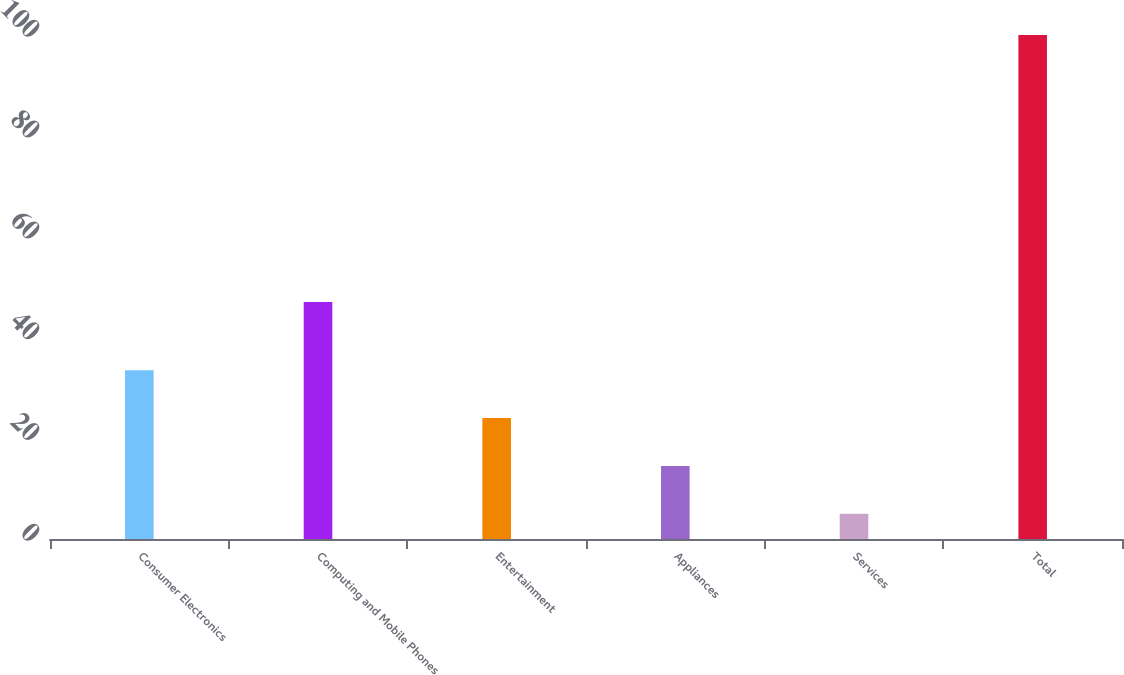<chart> <loc_0><loc_0><loc_500><loc_500><bar_chart><fcel>Consumer Electronics<fcel>Computing and Mobile Phones<fcel>Entertainment<fcel>Appliances<fcel>Services<fcel>Total<nl><fcel>33.5<fcel>47<fcel>24<fcel>14.5<fcel>5<fcel>100<nl></chart> 